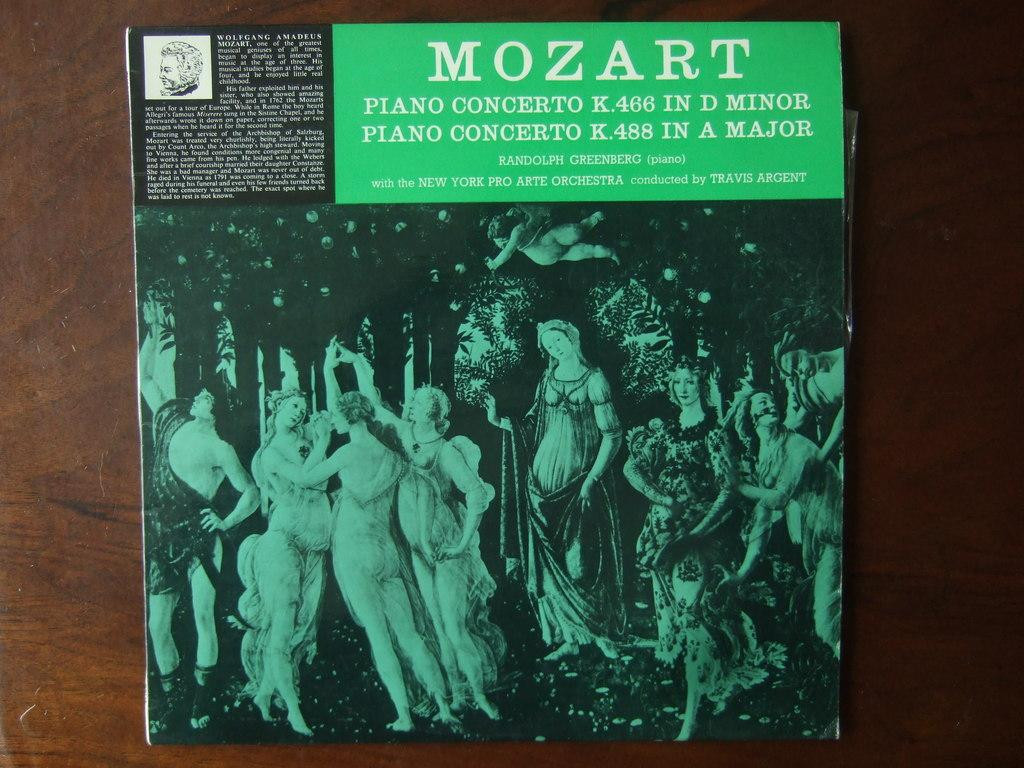What is on the poster in the image? There is a poster with text and a picture in the image. Where is the poster located? The poster is placed on a table. What can be seen in the picture on the poster? There are people and trees in the picture on the poster. What is the chance of winning a pan in the image? There is no mention of a pan or winning in the image, so it is not possible to determine the chance of winning a pan. 